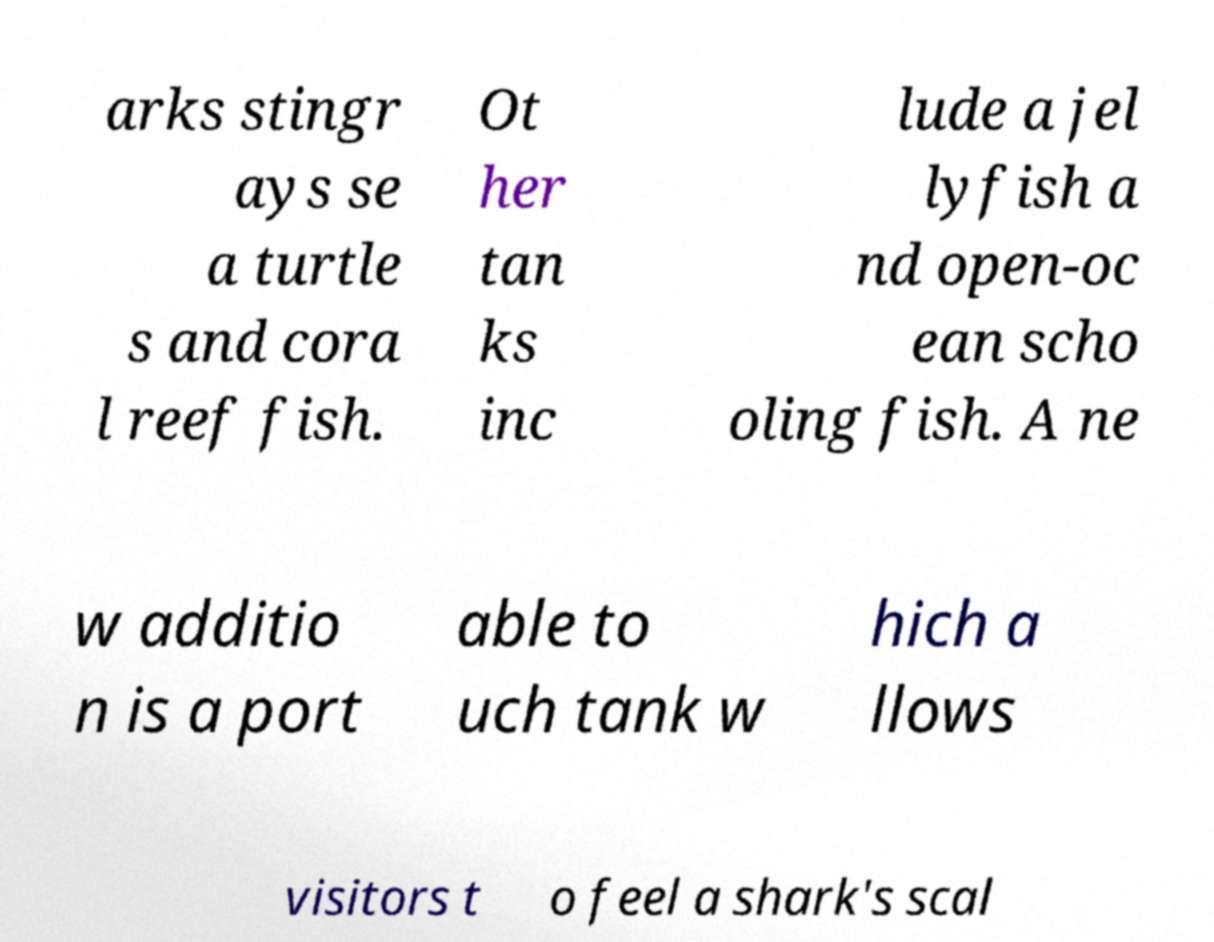Can you read and provide the text displayed in the image?This photo seems to have some interesting text. Can you extract and type it out for me? arks stingr ays se a turtle s and cora l reef fish. Ot her tan ks inc lude a jel lyfish a nd open-oc ean scho oling fish. A ne w additio n is a port able to uch tank w hich a llows visitors t o feel a shark's scal 